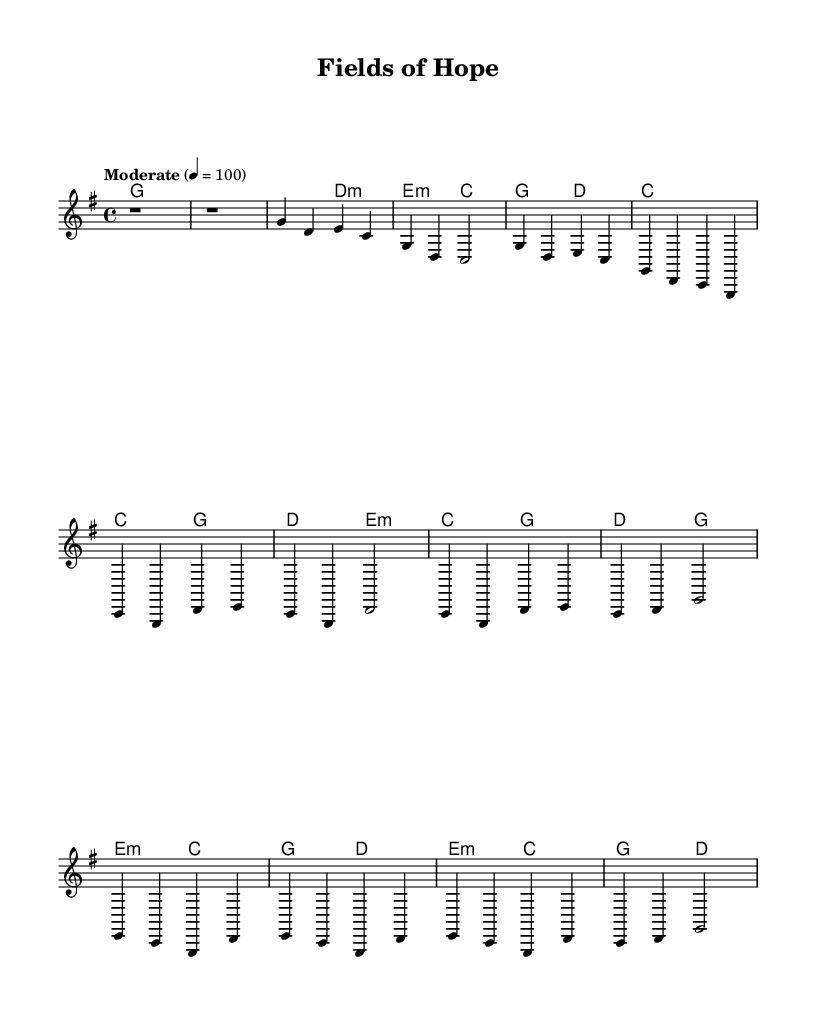What is the key signature of this music? The key signature is indicated by the `\key` directive in the code, which is set to G major. G major has one sharp (F#).
Answer: G major What is the time signature of this music? The time signature is found in the `\time` directive, which specifies a 4/4 time signature, meaning there are four beats in a measure and the quarter note gets one beat.
Answer: 4/4 What is the tempo marking for this music? The tempo is indicated in the `\tempo` directive which states "Moderate" with a metronome marking of 4 = 100, meaning the quarter note should be played at 100 beats per minute.
Answer: Moderate 4 = 100 How many measures are in the chorus section? By counting the segments labeled as the chorus in the melody and harmonies, we see there are 4 measures in the chorus section.
Answer: 4 Which chords are used in the bridge? The bridge includes the chords specified in the `harmonies` section, which are e minor, c major, g major, and d major.
Answer: e minor, c major, g major, d major What is the relation between the verse and the chorus in terms of structure? The verse consists of two phrases with a total of 8 measures, while the chorus has 4 distinct measures. The chorus serves as a contrast and a lift from the verse.
Answer: Contrast and lift What themes might the lyrics explore in “Fields of Hope”? Given the title and the focus on the immigrant experience in rural America, the themes likely include hope, struggle, and resilience.
Answer: Hope, struggle, resilience 